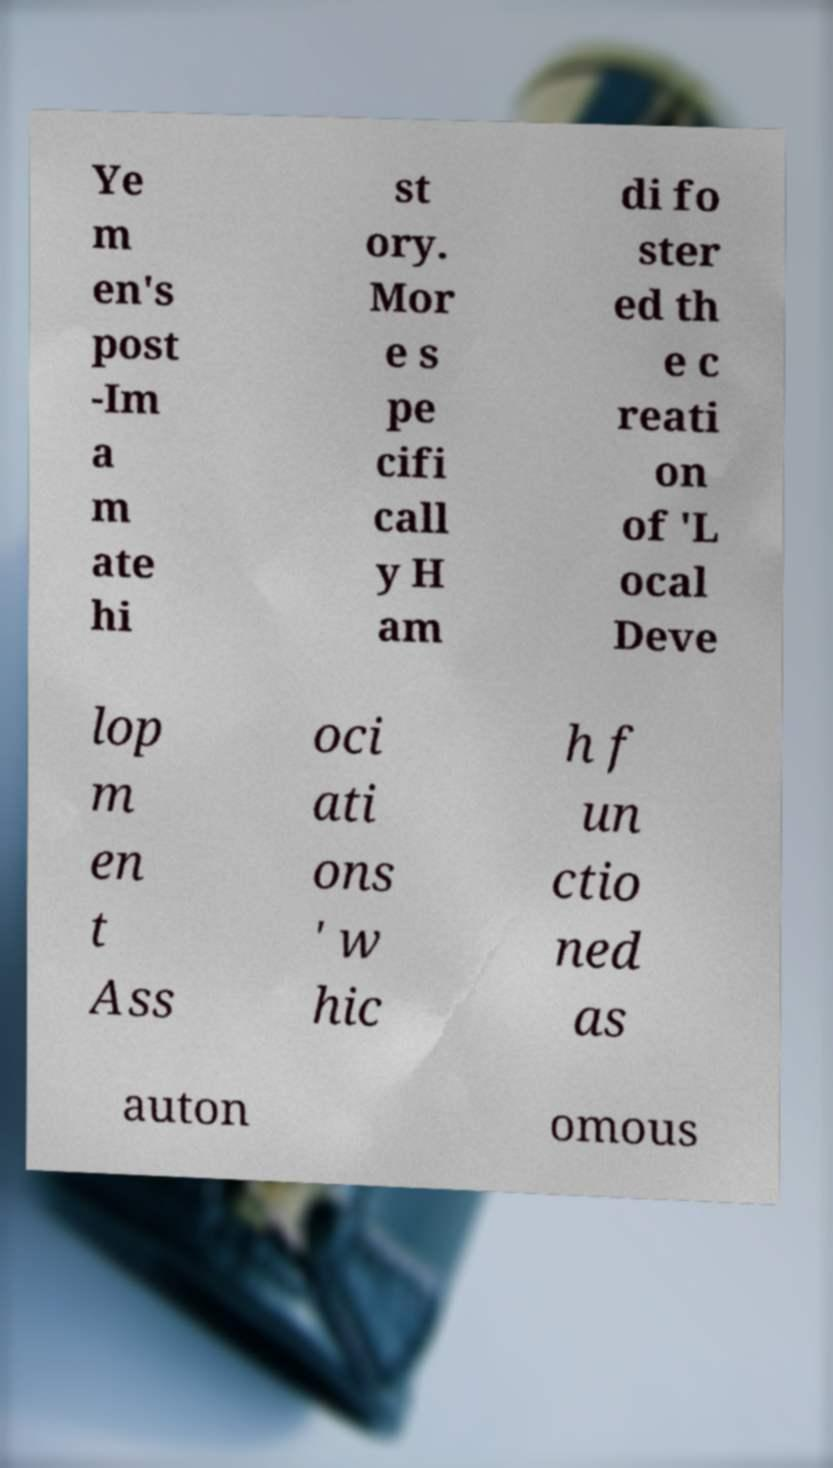There's text embedded in this image that I need extracted. Can you transcribe it verbatim? Ye m en's post -Im a m ate hi st ory. Mor e s pe cifi call y H am di fo ster ed th e c reati on of 'L ocal Deve lop m en t Ass oci ati ons ' w hic h f un ctio ned as auton omous 